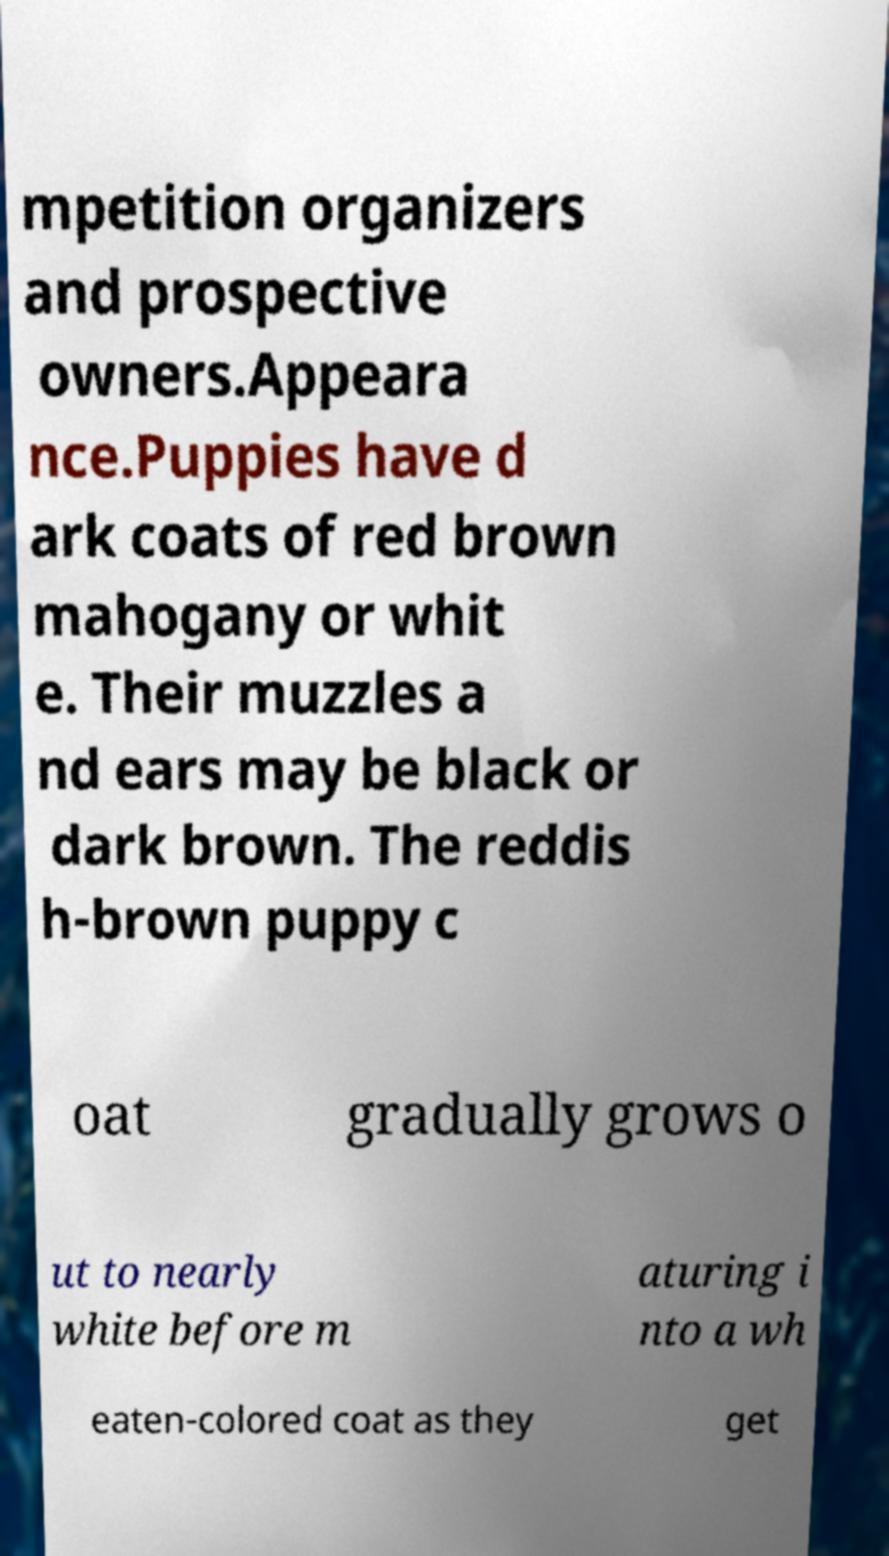There's text embedded in this image that I need extracted. Can you transcribe it verbatim? mpetition organizers and prospective owners.Appeara nce.Puppies have d ark coats of red brown mahogany or whit e. Their muzzles a nd ears may be black or dark brown. The reddis h-brown puppy c oat gradually grows o ut to nearly white before m aturing i nto a wh eaten-colored coat as they get 